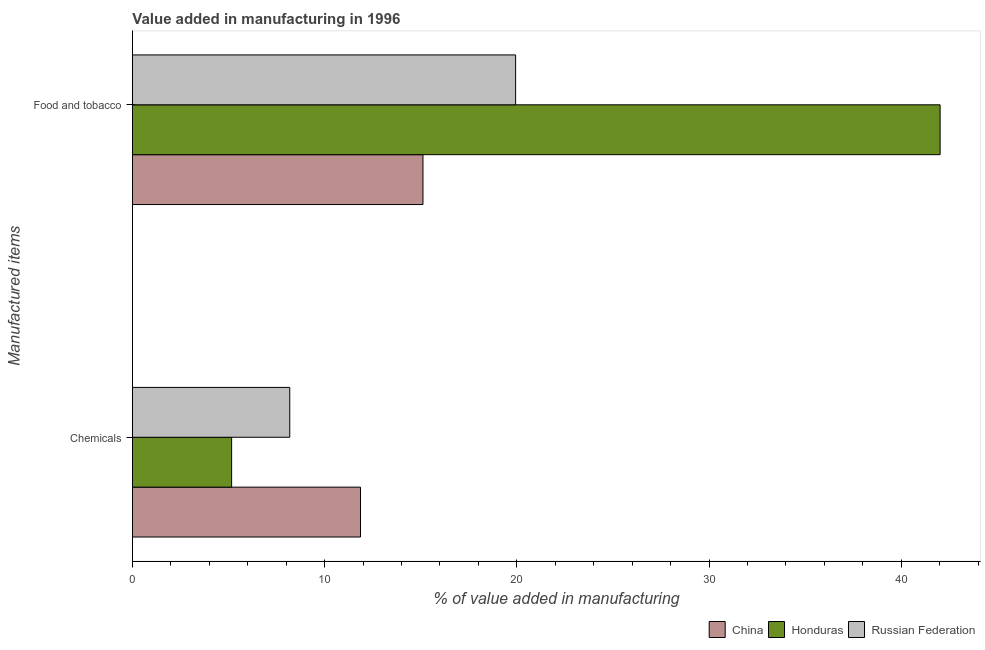How many groups of bars are there?
Offer a terse response. 2. Are the number of bars per tick equal to the number of legend labels?
Provide a succinct answer. Yes. Are the number of bars on each tick of the Y-axis equal?
Keep it short and to the point. Yes. How many bars are there on the 1st tick from the top?
Ensure brevity in your answer.  3. What is the label of the 1st group of bars from the top?
Your answer should be very brief. Food and tobacco. What is the value added by manufacturing food and tobacco in China?
Provide a short and direct response. 15.12. Across all countries, what is the maximum value added by manufacturing food and tobacco?
Offer a very short reply. 42.03. Across all countries, what is the minimum value added by manufacturing food and tobacco?
Offer a terse response. 15.12. In which country was the value added by manufacturing food and tobacco minimum?
Offer a very short reply. China. What is the total value added by manufacturing food and tobacco in the graph?
Make the answer very short. 77.08. What is the difference between the value added by manufacturing food and tobacco in Honduras and that in Russian Federation?
Keep it short and to the point. 22.09. What is the difference between the value added by manufacturing food and tobacco in Honduras and the value added by  manufacturing chemicals in Russian Federation?
Give a very brief answer. 33.84. What is the average value added by manufacturing food and tobacco per country?
Provide a short and direct response. 25.69. What is the difference between the value added by  manufacturing chemicals and value added by manufacturing food and tobacco in Honduras?
Make the answer very short. -36.86. In how many countries, is the value added by  manufacturing chemicals greater than 16 %?
Offer a terse response. 0. What is the ratio of the value added by  manufacturing chemicals in Russian Federation to that in Honduras?
Your answer should be very brief. 1.59. Is the value added by  manufacturing chemicals in Russian Federation less than that in Honduras?
Provide a short and direct response. No. What does the 2nd bar from the top in Chemicals represents?
Provide a short and direct response. Honduras. What does the 3rd bar from the bottom in Chemicals represents?
Keep it short and to the point. Russian Federation. How many bars are there?
Ensure brevity in your answer.  6. What is the difference between two consecutive major ticks on the X-axis?
Make the answer very short. 10. Are the values on the major ticks of X-axis written in scientific E-notation?
Provide a short and direct response. No. Where does the legend appear in the graph?
Offer a very short reply. Bottom right. How many legend labels are there?
Provide a succinct answer. 3. What is the title of the graph?
Ensure brevity in your answer.  Value added in manufacturing in 1996. What is the label or title of the X-axis?
Ensure brevity in your answer.  % of value added in manufacturing. What is the label or title of the Y-axis?
Keep it short and to the point. Manufactured items. What is the % of value added in manufacturing of China in Chemicals?
Make the answer very short. 11.87. What is the % of value added in manufacturing of Honduras in Chemicals?
Offer a very short reply. 5.16. What is the % of value added in manufacturing of Russian Federation in Chemicals?
Give a very brief answer. 8.19. What is the % of value added in manufacturing of China in Food and tobacco?
Make the answer very short. 15.12. What is the % of value added in manufacturing of Honduras in Food and tobacco?
Offer a terse response. 42.03. What is the % of value added in manufacturing of Russian Federation in Food and tobacco?
Make the answer very short. 19.94. Across all Manufactured items, what is the maximum % of value added in manufacturing of China?
Give a very brief answer. 15.12. Across all Manufactured items, what is the maximum % of value added in manufacturing of Honduras?
Offer a terse response. 42.03. Across all Manufactured items, what is the maximum % of value added in manufacturing of Russian Federation?
Keep it short and to the point. 19.94. Across all Manufactured items, what is the minimum % of value added in manufacturing of China?
Your answer should be compact. 11.87. Across all Manufactured items, what is the minimum % of value added in manufacturing in Honduras?
Your answer should be compact. 5.16. Across all Manufactured items, what is the minimum % of value added in manufacturing of Russian Federation?
Offer a terse response. 8.19. What is the total % of value added in manufacturing of China in the graph?
Make the answer very short. 26.98. What is the total % of value added in manufacturing of Honduras in the graph?
Offer a terse response. 47.19. What is the total % of value added in manufacturing in Russian Federation in the graph?
Your response must be concise. 28.12. What is the difference between the % of value added in manufacturing in China in Chemicals and that in Food and tobacco?
Your answer should be very brief. -3.25. What is the difference between the % of value added in manufacturing of Honduras in Chemicals and that in Food and tobacco?
Ensure brevity in your answer.  -36.86. What is the difference between the % of value added in manufacturing of Russian Federation in Chemicals and that in Food and tobacco?
Provide a succinct answer. -11.75. What is the difference between the % of value added in manufacturing in China in Chemicals and the % of value added in manufacturing in Honduras in Food and tobacco?
Make the answer very short. -30.16. What is the difference between the % of value added in manufacturing of China in Chemicals and the % of value added in manufacturing of Russian Federation in Food and tobacco?
Your answer should be very brief. -8.07. What is the difference between the % of value added in manufacturing of Honduras in Chemicals and the % of value added in manufacturing of Russian Federation in Food and tobacco?
Keep it short and to the point. -14.78. What is the average % of value added in manufacturing of China per Manufactured items?
Provide a short and direct response. 13.49. What is the average % of value added in manufacturing in Honduras per Manufactured items?
Your answer should be very brief. 23.59. What is the average % of value added in manufacturing in Russian Federation per Manufactured items?
Give a very brief answer. 14.06. What is the difference between the % of value added in manufacturing of China and % of value added in manufacturing of Honduras in Chemicals?
Offer a very short reply. 6.71. What is the difference between the % of value added in manufacturing in China and % of value added in manufacturing in Russian Federation in Chemicals?
Your answer should be very brief. 3.68. What is the difference between the % of value added in manufacturing in Honduras and % of value added in manufacturing in Russian Federation in Chemicals?
Your response must be concise. -3.02. What is the difference between the % of value added in manufacturing of China and % of value added in manufacturing of Honduras in Food and tobacco?
Give a very brief answer. -26.91. What is the difference between the % of value added in manufacturing of China and % of value added in manufacturing of Russian Federation in Food and tobacco?
Ensure brevity in your answer.  -4.82. What is the difference between the % of value added in manufacturing of Honduras and % of value added in manufacturing of Russian Federation in Food and tobacco?
Keep it short and to the point. 22.09. What is the ratio of the % of value added in manufacturing of China in Chemicals to that in Food and tobacco?
Offer a very short reply. 0.79. What is the ratio of the % of value added in manufacturing of Honduras in Chemicals to that in Food and tobacco?
Ensure brevity in your answer.  0.12. What is the ratio of the % of value added in manufacturing of Russian Federation in Chemicals to that in Food and tobacco?
Your answer should be very brief. 0.41. What is the difference between the highest and the second highest % of value added in manufacturing of China?
Give a very brief answer. 3.25. What is the difference between the highest and the second highest % of value added in manufacturing of Honduras?
Your answer should be compact. 36.86. What is the difference between the highest and the second highest % of value added in manufacturing in Russian Federation?
Your answer should be very brief. 11.75. What is the difference between the highest and the lowest % of value added in manufacturing of China?
Your response must be concise. 3.25. What is the difference between the highest and the lowest % of value added in manufacturing of Honduras?
Provide a short and direct response. 36.86. What is the difference between the highest and the lowest % of value added in manufacturing of Russian Federation?
Offer a very short reply. 11.75. 